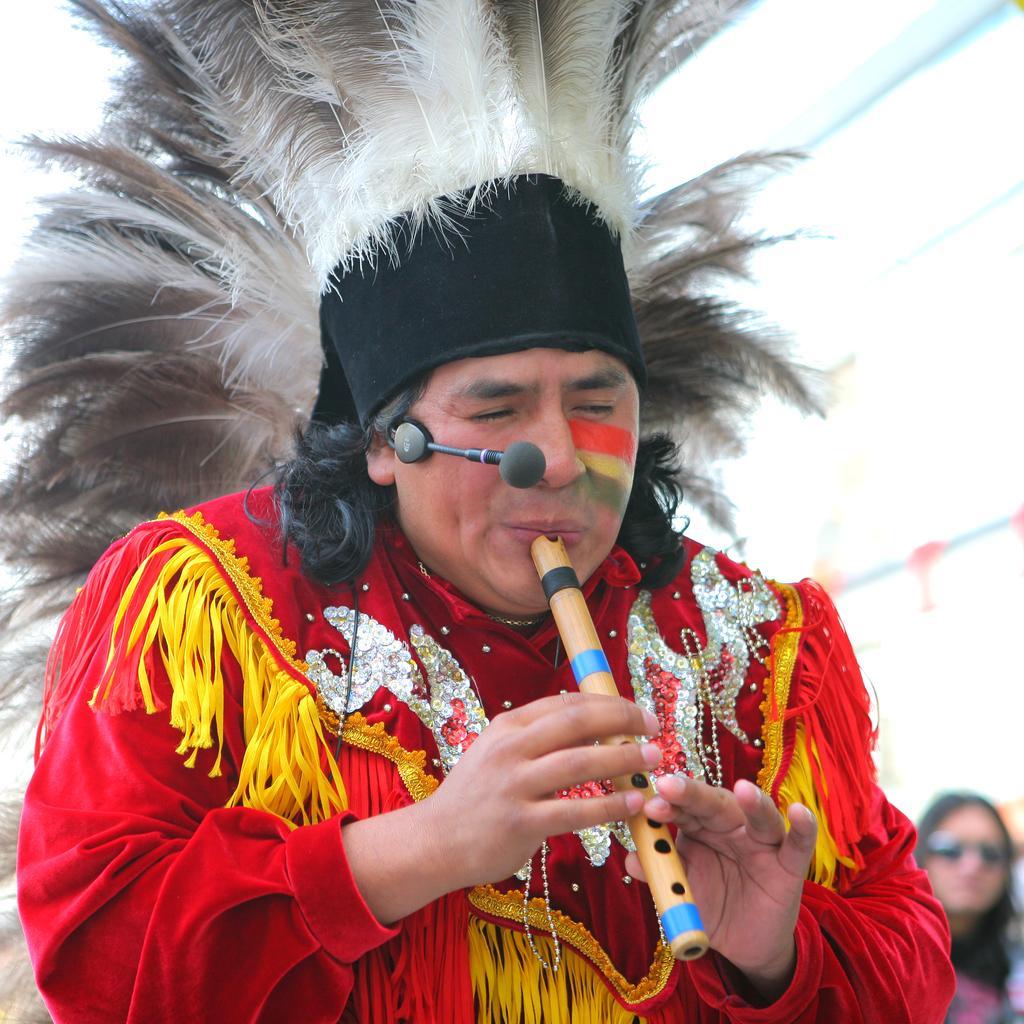Could you give a brief overview of what you see in this image? Here we can see a person wearing something on his head with a microphone present and playing a flute 